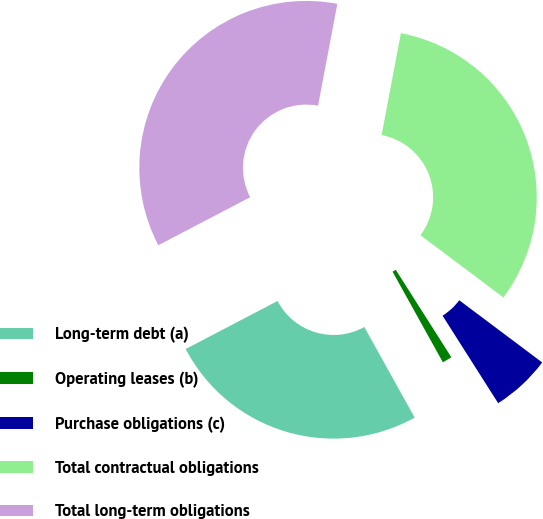Convert chart to OTSL. <chart><loc_0><loc_0><loc_500><loc_500><pie_chart><fcel>Long-term debt (a)<fcel>Operating leases (b)<fcel>Purchase obligations (c)<fcel>Total contractual obligations<fcel>Total long-term obligations<nl><fcel>25.4%<fcel>0.94%<fcel>5.75%<fcel>32.26%<fcel>35.65%<nl></chart> 